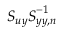Convert formula to latex. <formula><loc_0><loc_0><loc_500><loc_500>S _ { u y } S _ { y y , n } ^ { - 1 }</formula> 